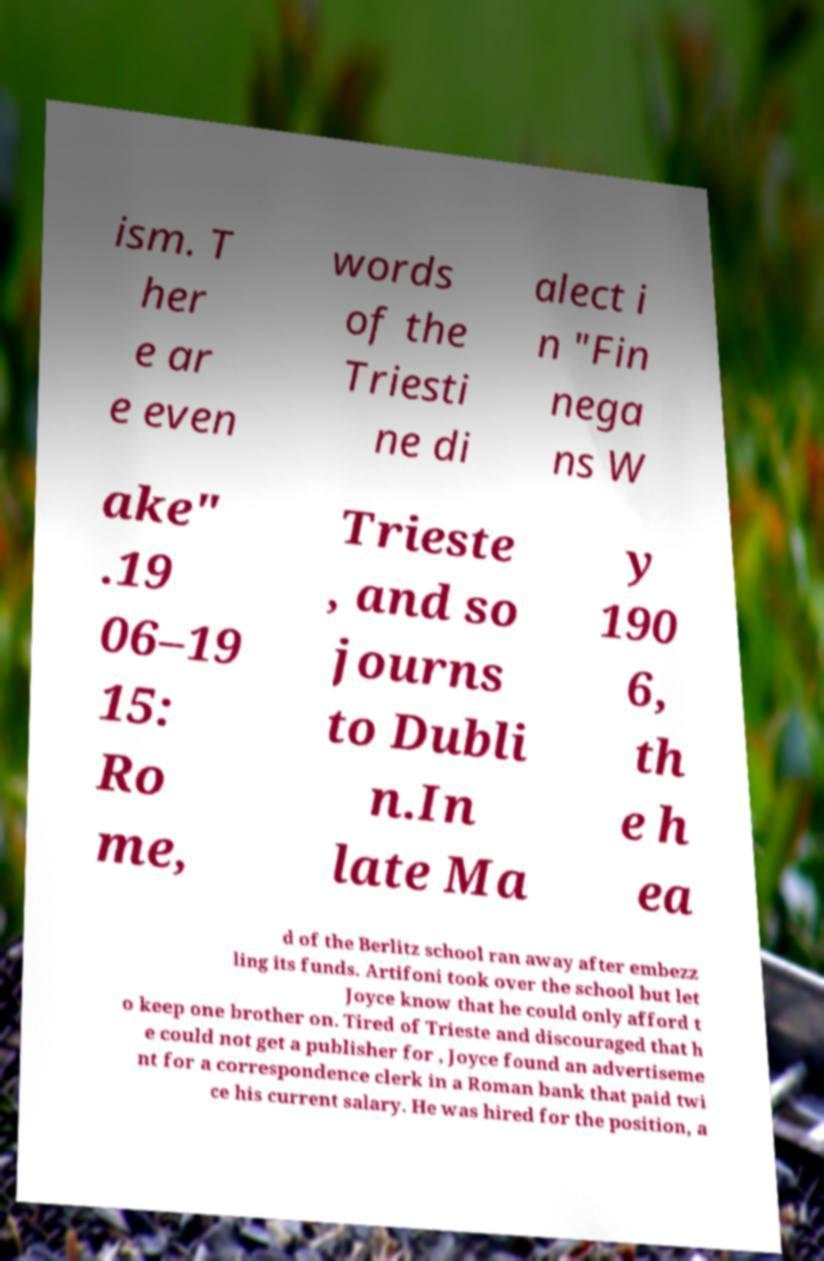What messages or text are displayed in this image? I need them in a readable, typed format. ism. T her e ar e even words of the Triesti ne di alect i n "Fin nega ns W ake" .19 06–19 15: Ro me, Trieste , and so journs to Dubli n.In late Ma y 190 6, th e h ea d of the Berlitz school ran away after embezz ling its funds. Artifoni took over the school but let Joyce know that he could only afford t o keep one brother on. Tired of Trieste and discouraged that h e could not get a publisher for , Joyce found an advertiseme nt for a correspondence clerk in a Roman bank that paid twi ce his current salary. He was hired for the position, a 